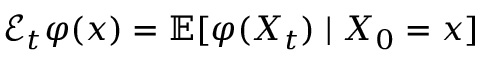<formula> <loc_0><loc_0><loc_500><loc_500>{ \mathcal { E } } _ { t } \varphi ( x ) = \mathbb { E } [ \varphi ( X _ { t } ) | X _ { 0 } = x ]</formula> 